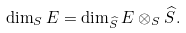Convert formula to latex. <formula><loc_0><loc_0><loc_500><loc_500>\dim _ { S } E = \dim _ { \widehat { S } } E \otimes _ { S } \widehat { S } .</formula> 